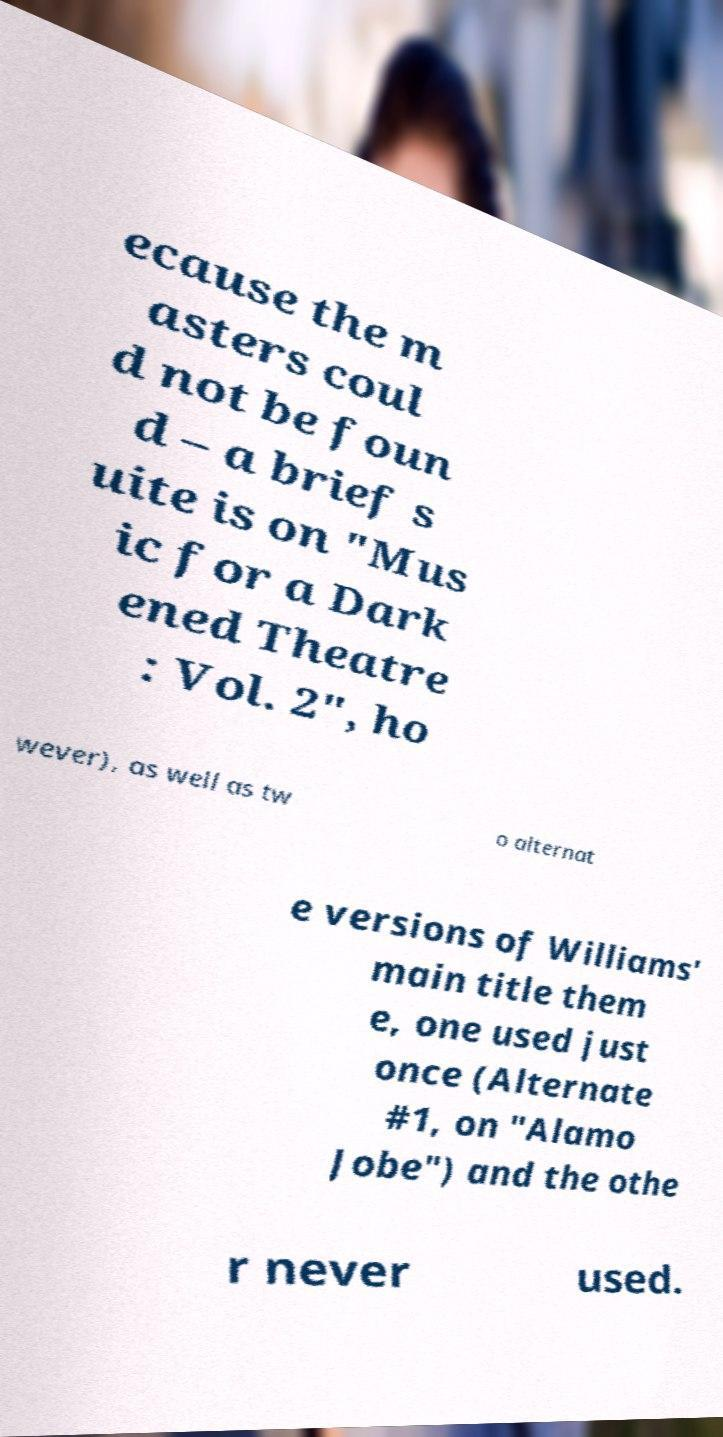Can you accurately transcribe the text from the provided image for me? ecause the m asters coul d not be foun d – a brief s uite is on "Mus ic for a Dark ened Theatre : Vol. 2", ho wever), as well as tw o alternat e versions of Williams' main title them e, one used just once (Alternate #1, on "Alamo Jobe") and the othe r never used. 